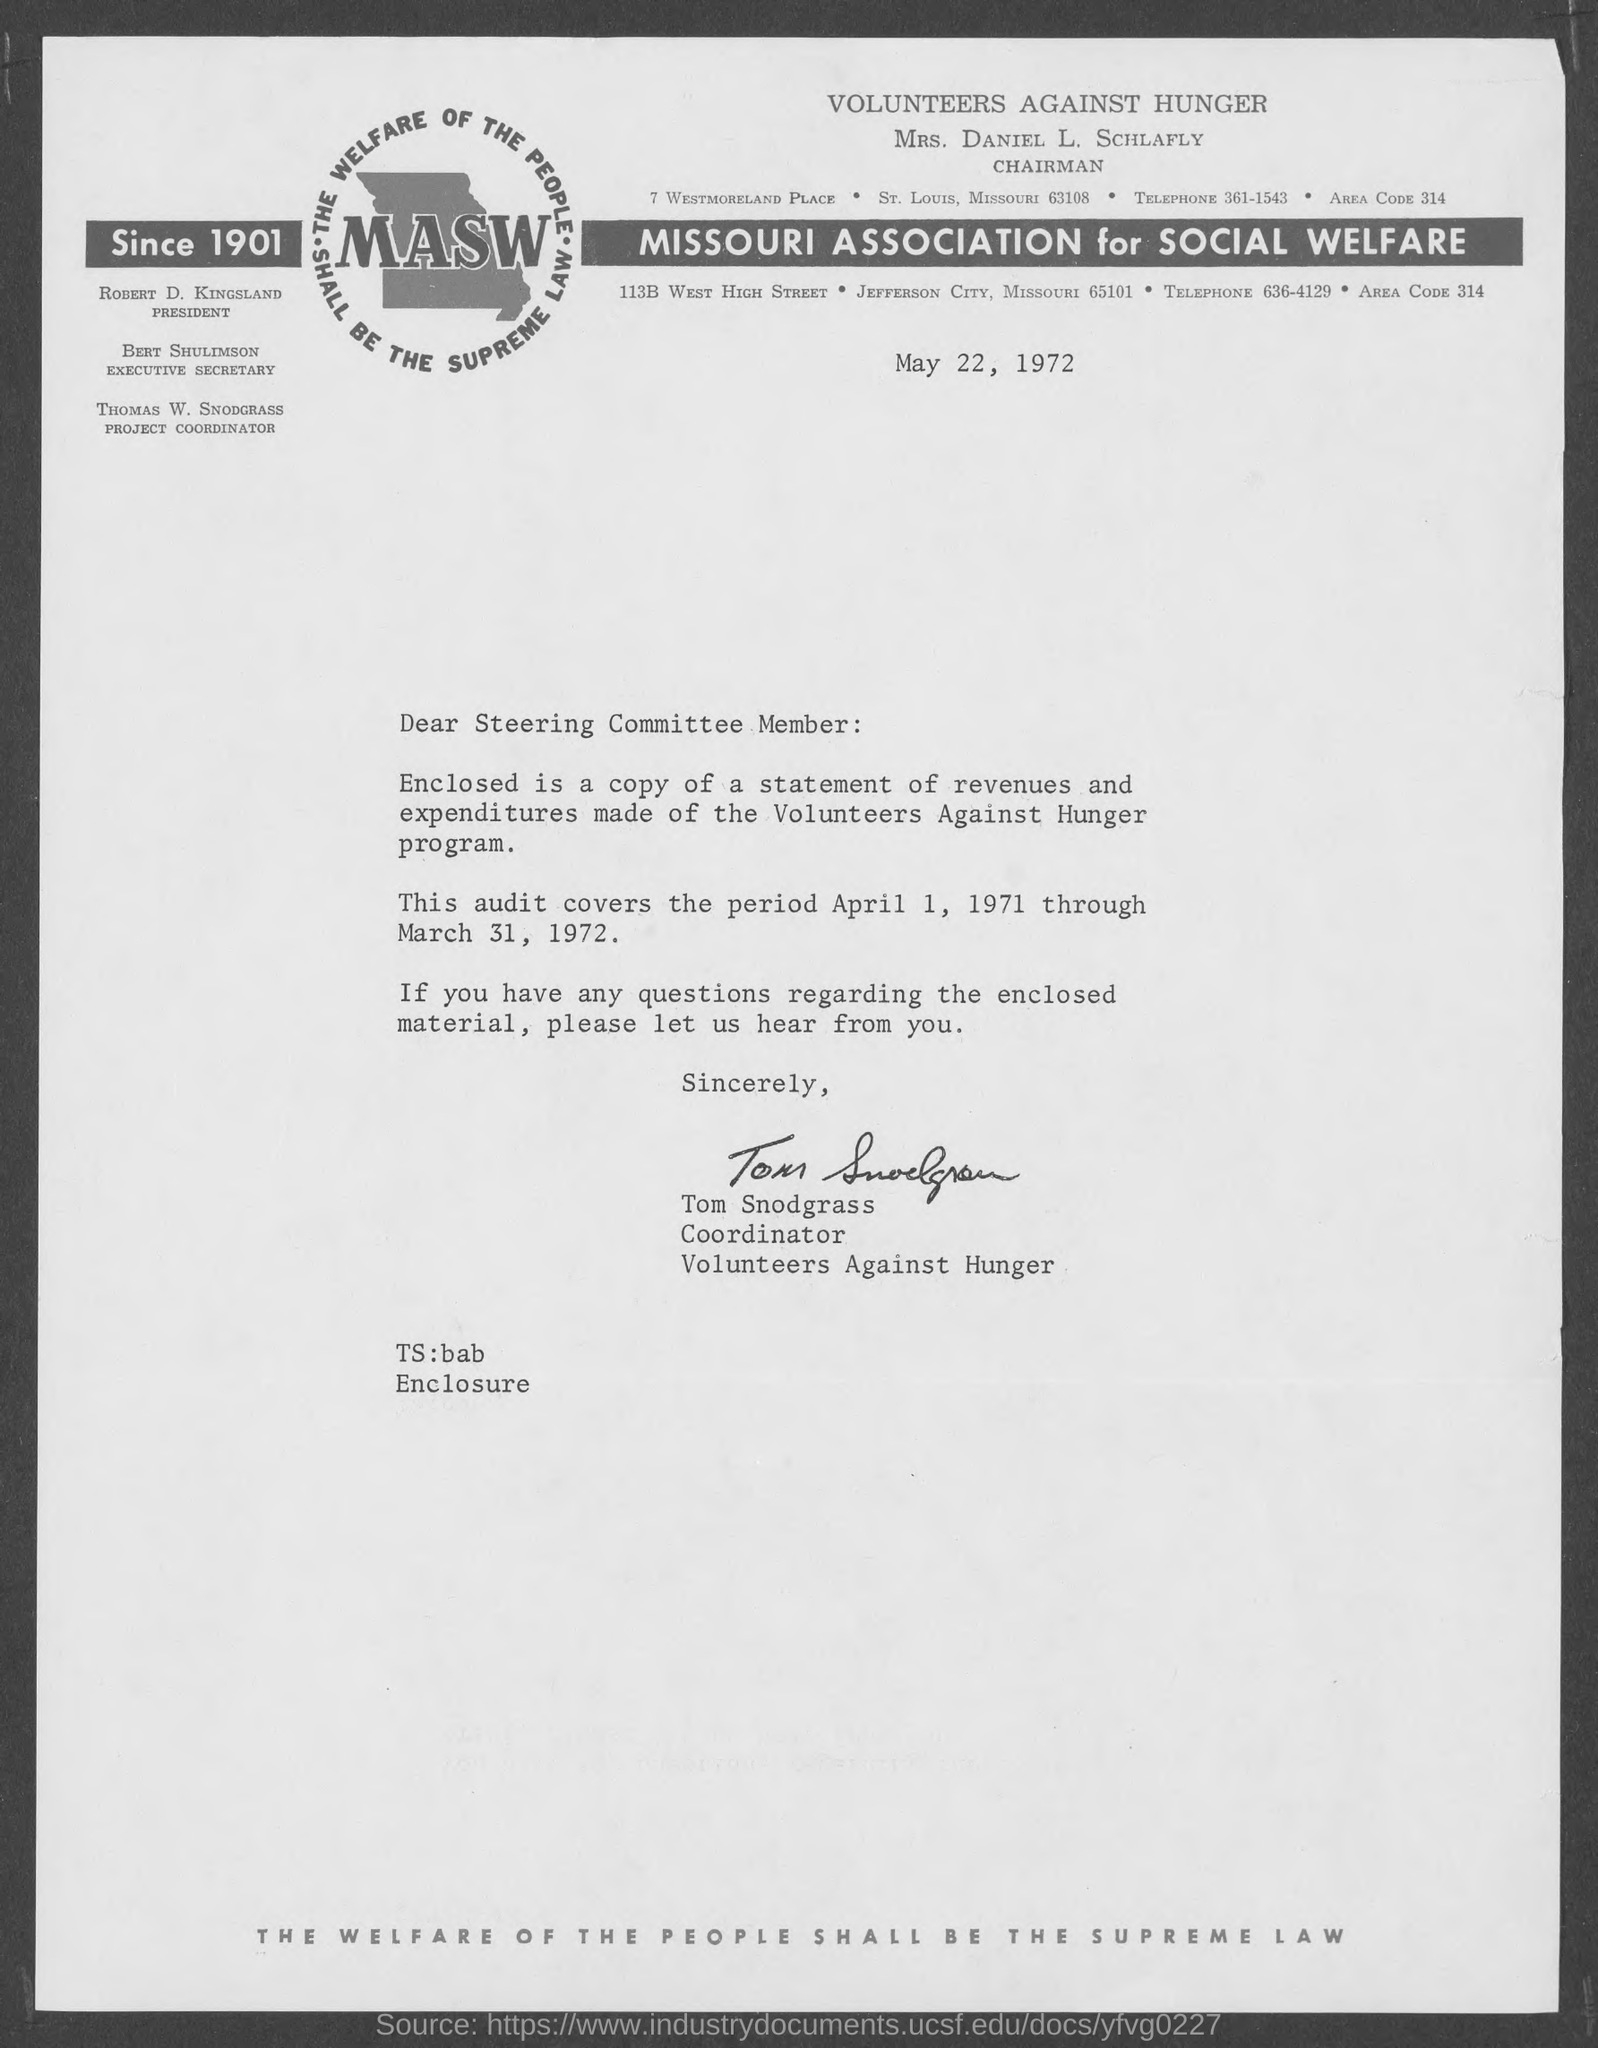Who is the Chairman of VOLUNTEERS AGAINST HUNGER?
Keep it short and to the point. MRS. DANIEL L. SCHLAFLY. Since when is MASW?
Make the answer very short. Since 1901. What does MASW stand for?
Your answer should be compact. MISSOURI ASSOCIATION for SOCIAL WELFARE. When is the document dated?
Give a very brief answer. May 22, 1972. Who is the President?
Give a very brief answer. ROBERT D. KINGSLAND. What is Bert Shulimson's title?
Your response must be concise. EXECUTIVE SECRETARY. What period does the enclosed audit cover?
Provide a succinct answer. April 1, 1971 through March 31, 1972. 